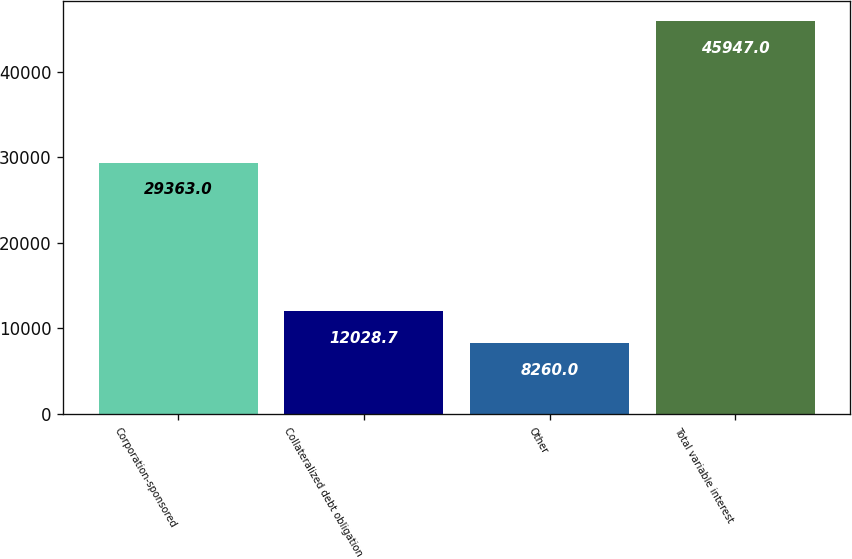<chart> <loc_0><loc_0><loc_500><loc_500><bar_chart><fcel>Corporation-sponsored<fcel>Collateralized debt obligation<fcel>Other<fcel>Total variable interest<nl><fcel>29363<fcel>12028.7<fcel>8260<fcel>45947<nl></chart> 